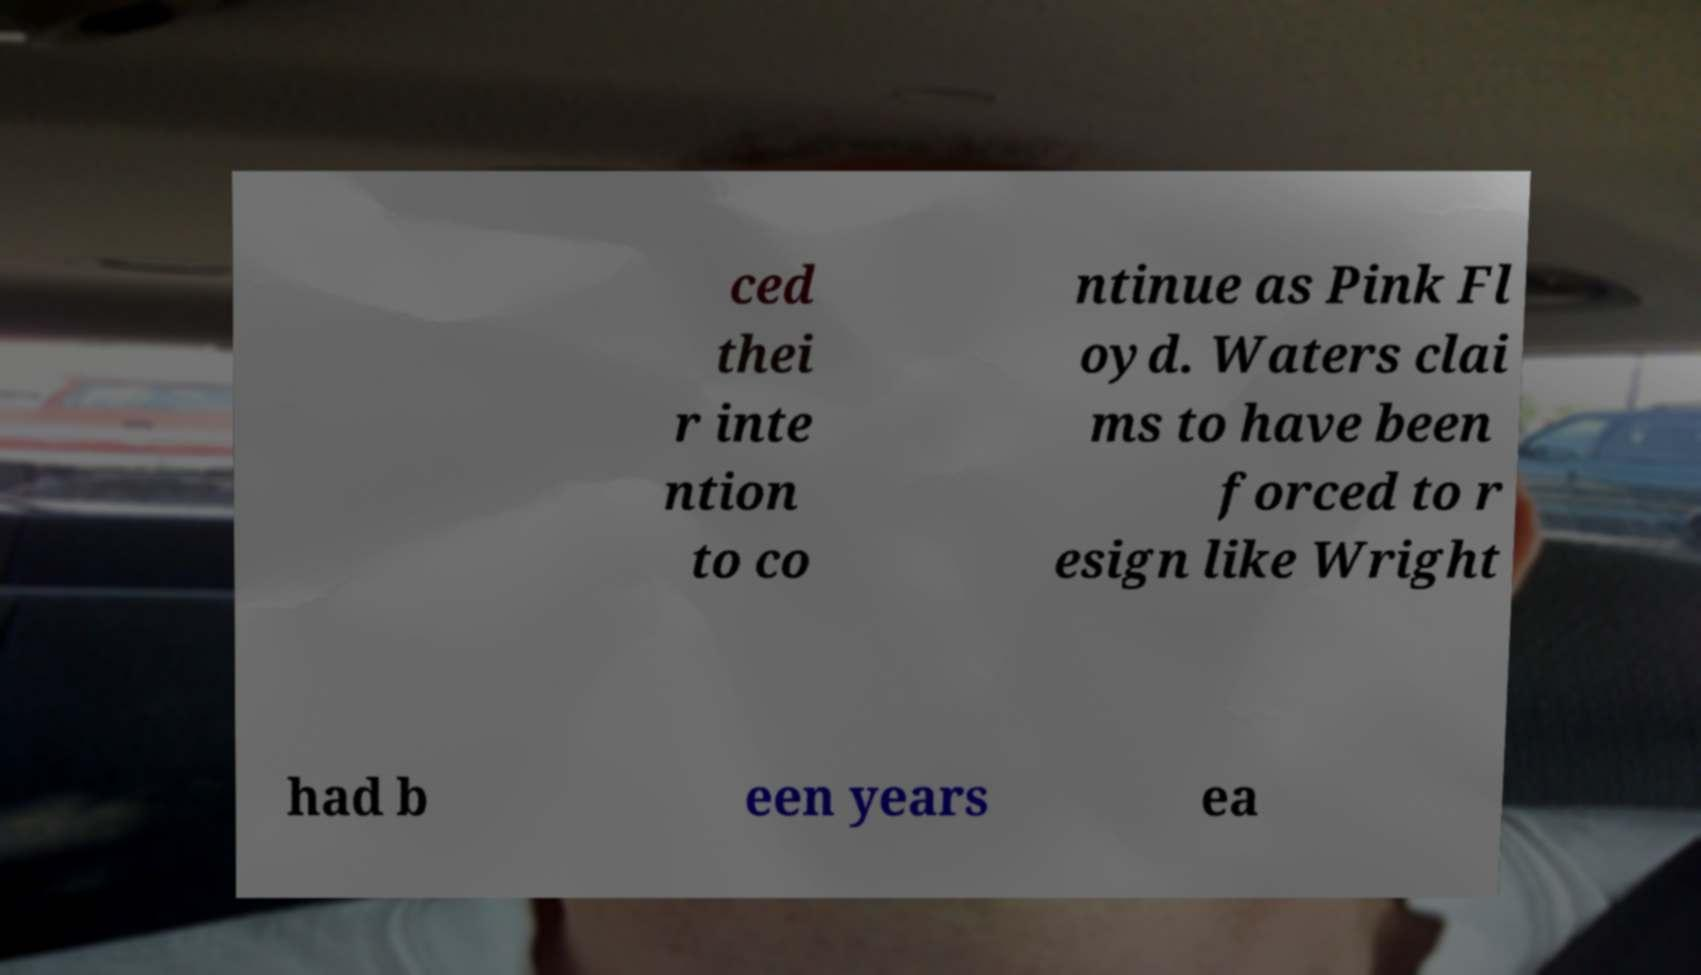Could you extract and type out the text from this image? ced thei r inte ntion to co ntinue as Pink Fl oyd. Waters clai ms to have been forced to r esign like Wright had b een years ea 